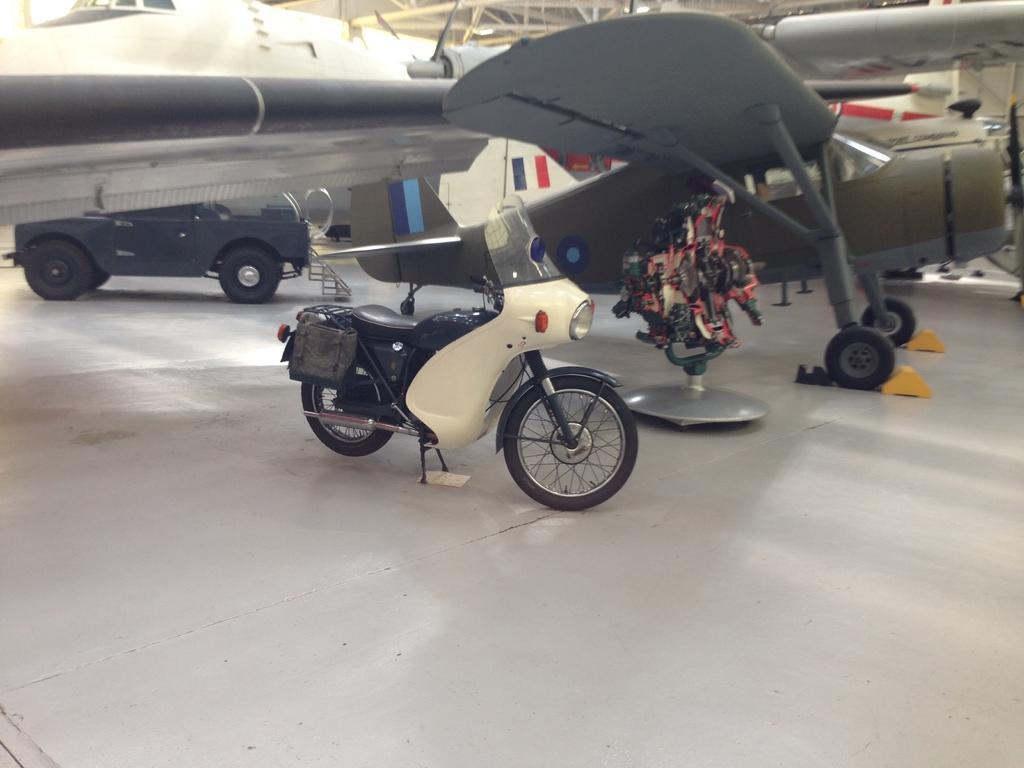How would you summarize this image in a sentence or two? In this image I can see a motorcycle, a vehicle, an aircraft and on it I can see few logos are printed. I can also see red and black colour thing over here. 